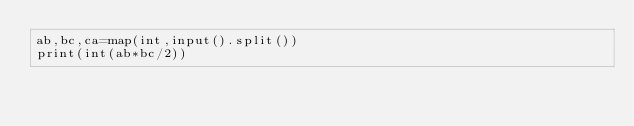<code> <loc_0><loc_0><loc_500><loc_500><_Python_>ab,bc,ca=map(int,input().split())
print(int(ab*bc/2))</code> 